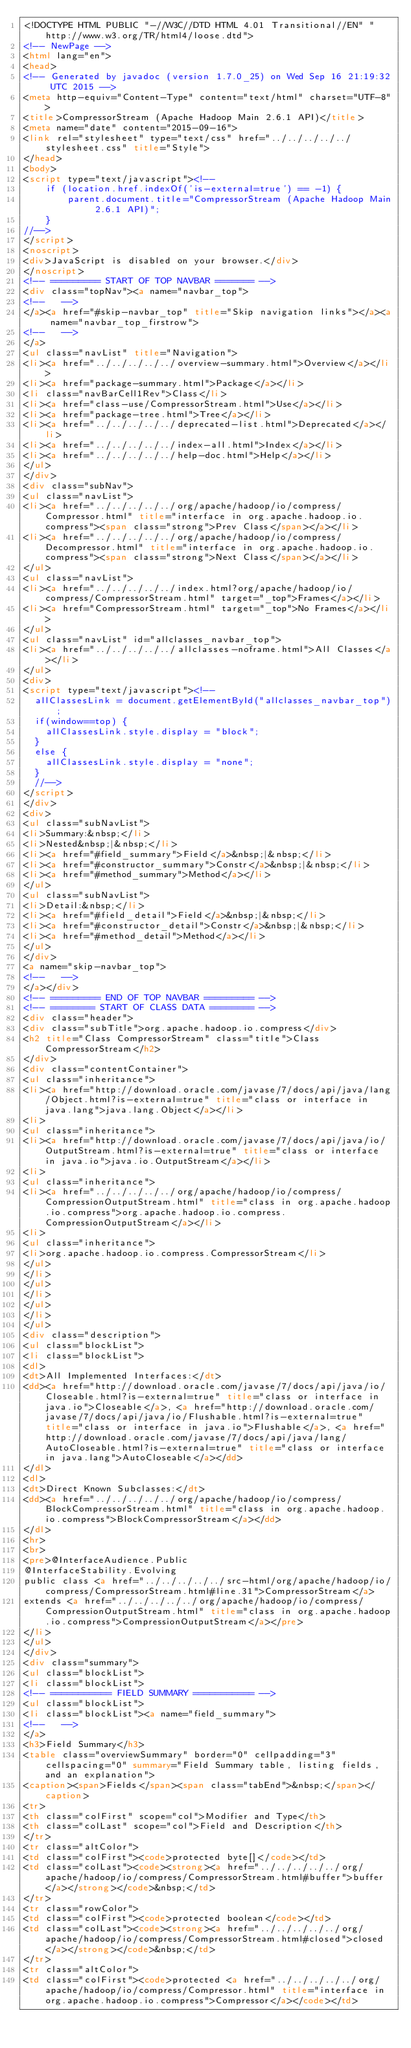Convert code to text. <code><loc_0><loc_0><loc_500><loc_500><_HTML_><!DOCTYPE HTML PUBLIC "-//W3C//DTD HTML 4.01 Transitional//EN" "http://www.w3.org/TR/html4/loose.dtd">
<!-- NewPage -->
<html lang="en">
<head>
<!-- Generated by javadoc (version 1.7.0_25) on Wed Sep 16 21:19:32 UTC 2015 -->
<meta http-equiv="Content-Type" content="text/html" charset="UTF-8">
<title>CompressorStream (Apache Hadoop Main 2.6.1 API)</title>
<meta name="date" content="2015-09-16">
<link rel="stylesheet" type="text/css" href="../../../../../stylesheet.css" title="Style">
</head>
<body>
<script type="text/javascript"><!--
    if (location.href.indexOf('is-external=true') == -1) {
        parent.document.title="CompressorStream (Apache Hadoop Main 2.6.1 API)";
    }
//-->
</script>
<noscript>
<div>JavaScript is disabled on your browser.</div>
</noscript>
<!-- ========= START OF TOP NAVBAR ======= -->
<div class="topNav"><a name="navbar_top">
<!--   -->
</a><a href="#skip-navbar_top" title="Skip navigation links"></a><a name="navbar_top_firstrow">
<!--   -->
</a>
<ul class="navList" title="Navigation">
<li><a href="../../../../../overview-summary.html">Overview</a></li>
<li><a href="package-summary.html">Package</a></li>
<li class="navBarCell1Rev">Class</li>
<li><a href="class-use/CompressorStream.html">Use</a></li>
<li><a href="package-tree.html">Tree</a></li>
<li><a href="../../../../../deprecated-list.html">Deprecated</a></li>
<li><a href="../../../../../index-all.html">Index</a></li>
<li><a href="../../../../../help-doc.html">Help</a></li>
</ul>
</div>
<div class="subNav">
<ul class="navList">
<li><a href="../../../../../org/apache/hadoop/io/compress/Compressor.html" title="interface in org.apache.hadoop.io.compress"><span class="strong">Prev Class</span></a></li>
<li><a href="../../../../../org/apache/hadoop/io/compress/Decompressor.html" title="interface in org.apache.hadoop.io.compress"><span class="strong">Next Class</span></a></li>
</ul>
<ul class="navList">
<li><a href="../../../../../index.html?org/apache/hadoop/io/compress/CompressorStream.html" target="_top">Frames</a></li>
<li><a href="CompressorStream.html" target="_top">No Frames</a></li>
</ul>
<ul class="navList" id="allclasses_navbar_top">
<li><a href="../../../../../allclasses-noframe.html">All Classes</a></li>
</ul>
<div>
<script type="text/javascript"><!--
  allClassesLink = document.getElementById("allclasses_navbar_top");
  if(window==top) {
    allClassesLink.style.display = "block";
  }
  else {
    allClassesLink.style.display = "none";
  }
  //-->
</script>
</div>
<div>
<ul class="subNavList">
<li>Summary:&nbsp;</li>
<li>Nested&nbsp;|&nbsp;</li>
<li><a href="#field_summary">Field</a>&nbsp;|&nbsp;</li>
<li><a href="#constructor_summary">Constr</a>&nbsp;|&nbsp;</li>
<li><a href="#method_summary">Method</a></li>
</ul>
<ul class="subNavList">
<li>Detail:&nbsp;</li>
<li><a href="#field_detail">Field</a>&nbsp;|&nbsp;</li>
<li><a href="#constructor_detail">Constr</a>&nbsp;|&nbsp;</li>
<li><a href="#method_detail">Method</a></li>
</ul>
</div>
<a name="skip-navbar_top">
<!--   -->
</a></div>
<!-- ========= END OF TOP NAVBAR ========= -->
<!-- ======== START OF CLASS DATA ======== -->
<div class="header">
<div class="subTitle">org.apache.hadoop.io.compress</div>
<h2 title="Class CompressorStream" class="title">Class CompressorStream</h2>
</div>
<div class="contentContainer">
<ul class="inheritance">
<li><a href="http://download.oracle.com/javase/7/docs/api/java/lang/Object.html?is-external=true" title="class or interface in java.lang">java.lang.Object</a></li>
<li>
<ul class="inheritance">
<li><a href="http://download.oracle.com/javase/7/docs/api/java/io/OutputStream.html?is-external=true" title="class or interface in java.io">java.io.OutputStream</a></li>
<li>
<ul class="inheritance">
<li><a href="../../../../../org/apache/hadoop/io/compress/CompressionOutputStream.html" title="class in org.apache.hadoop.io.compress">org.apache.hadoop.io.compress.CompressionOutputStream</a></li>
<li>
<ul class="inheritance">
<li>org.apache.hadoop.io.compress.CompressorStream</li>
</ul>
</li>
</ul>
</li>
</ul>
</li>
</ul>
<div class="description">
<ul class="blockList">
<li class="blockList">
<dl>
<dt>All Implemented Interfaces:</dt>
<dd><a href="http://download.oracle.com/javase/7/docs/api/java/io/Closeable.html?is-external=true" title="class or interface in java.io">Closeable</a>, <a href="http://download.oracle.com/javase/7/docs/api/java/io/Flushable.html?is-external=true" title="class or interface in java.io">Flushable</a>, <a href="http://download.oracle.com/javase/7/docs/api/java/lang/AutoCloseable.html?is-external=true" title="class or interface in java.lang">AutoCloseable</a></dd>
</dl>
<dl>
<dt>Direct Known Subclasses:</dt>
<dd><a href="../../../../../org/apache/hadoop/io/compress/BlockCompressorStream.html" title="class in org.apache.hadoop.io.compress">BlockCompressorStream</a></dd>
</dl>
<hr>
<br>
<pre>@InterfaceAudience.Public
@InterfaceStability.Evolving
public class <a href="../../../../../src-html/org/apache/hadoop/io/compress/CompressorStream.html#line.31">CompressorStream</a>
extends <a href="../../../../../org/apache/hadoop/io/compress/CompressionOutputStream.html" title="class in org.apache.hadoop.io.compress">CompressionOutputStream</a></pre>
</li>
</ul>
</div>
<div class="summary">
<ul class="blockList">
<li class="blockList">
<!-- =========== FIELD SUMMARY =========== -->
<ul class="blockList">
<li class="blockList"><a name="field_summary">
<!--   -->
</a>
<h3>Field Summary</h3>
<table class="overviewSummary" border="0" cellpadding="3" cellspacing="0" summary="Field Summary table, listing fields, and an explanation">
<caption><span>Fields</span><span class="tabEnd">&nbsp;</span></caption>
<tr>
<th class="colFirst" scope="col">Modifier and Type</th>
<th class="colLast" scope="col">Field and Description</th>
</tr>
<tr class="altColor">
<td class="colFirst"><code>protected byte[]</code></td>
<td class="colLast"><code><strong><a href="../../../../../org/apache/hadoop/io/compress/CompressorStream.html#buffer">buffer</a></strong></code>&nbsp;</td>
</tr>
<tr class="rowColor">
<td class="colFirst"><code>protected boolean</code></td>
<td class="colLast"><code><strong><a href="../../../../../org/apache/hadoop/io/compress/CompressorStream.html#closed">closed</a></strong></code>&nbsp;</td>
</tr>
<tr class="altColor">
<td class="colFirst"><code>protected <a href="../../../../../org/apache/hadoop/io/compress/Compressor.html" title="interface in org.apache.hadoop.io.compress">Compressor</a></code></td></code> 